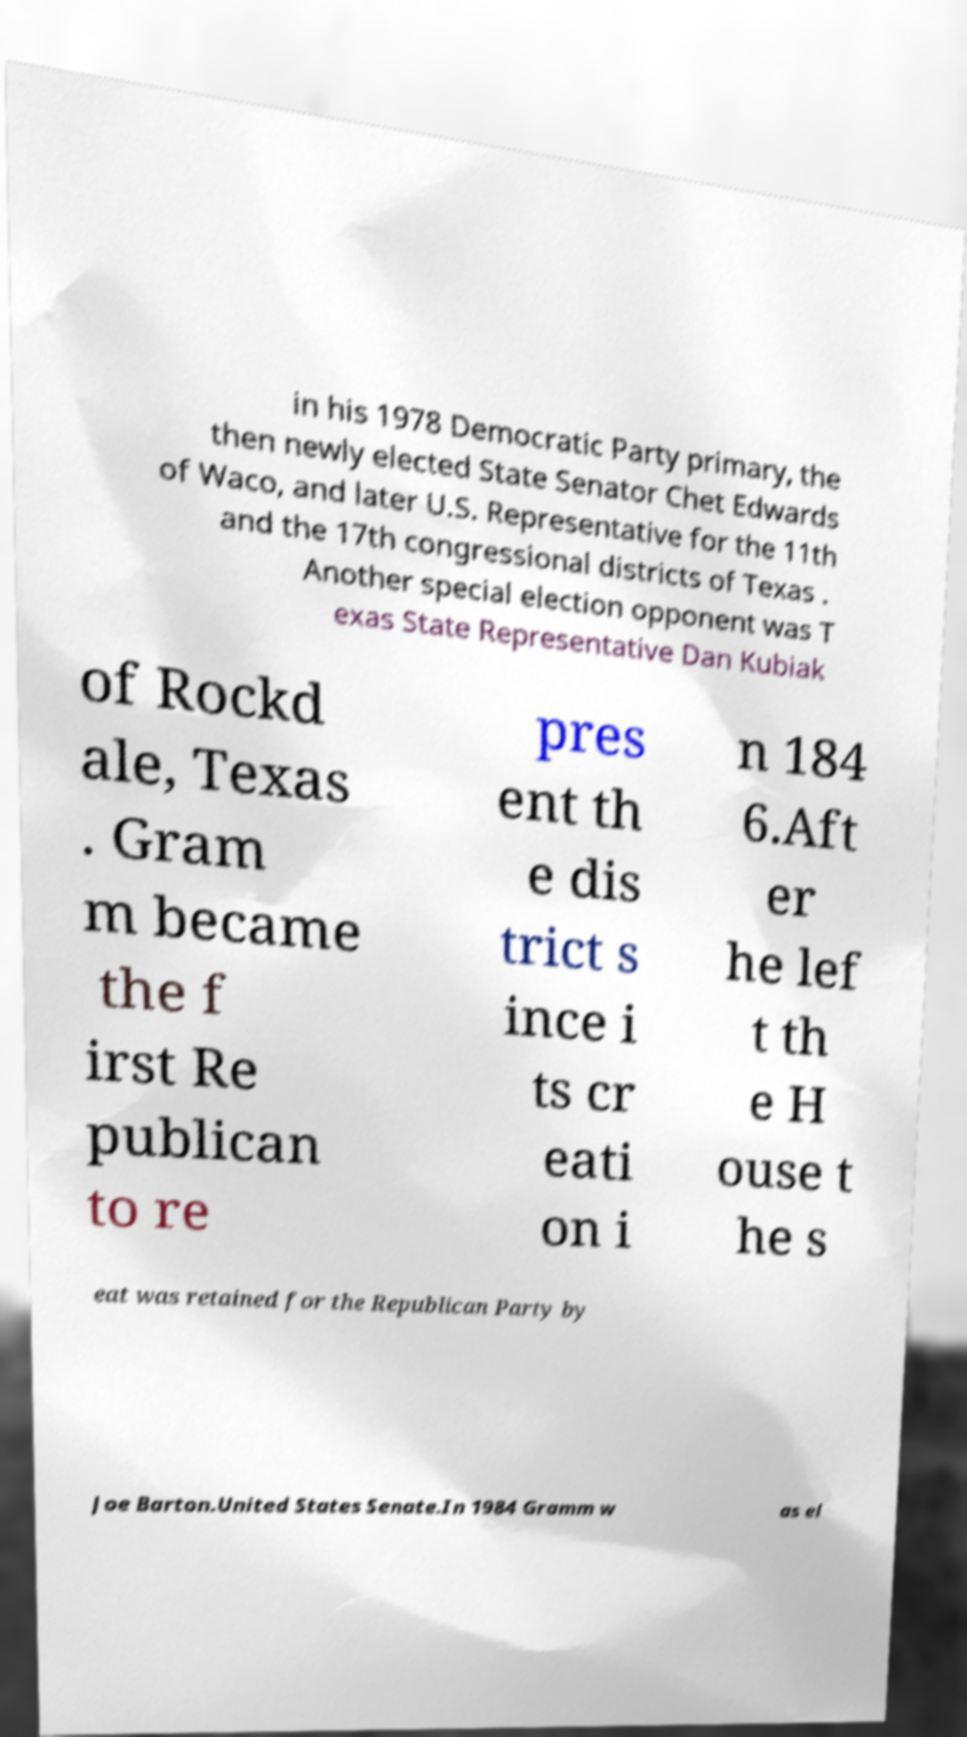Can you accurately transcribe the text from the provided image for me? in his 1978 Democratic Party primary, the then newly elected State Senator Chet Edwards of Waco, and later U.S. Representative for the 11th and the 17th congressional districts of Texas . Another special election opponent was T exas State Representative Dan Kubiak of Rockd ale, Texas . Gram m became the f irst Re publican to re pres ent th e dis trict s ince i ts cr eati on i n 184 6.Aft er he lef t th e H ouse t he s eat was retained for the Republican Party by Joe Barton.United States Senate.In 1984 Gramm w as el 